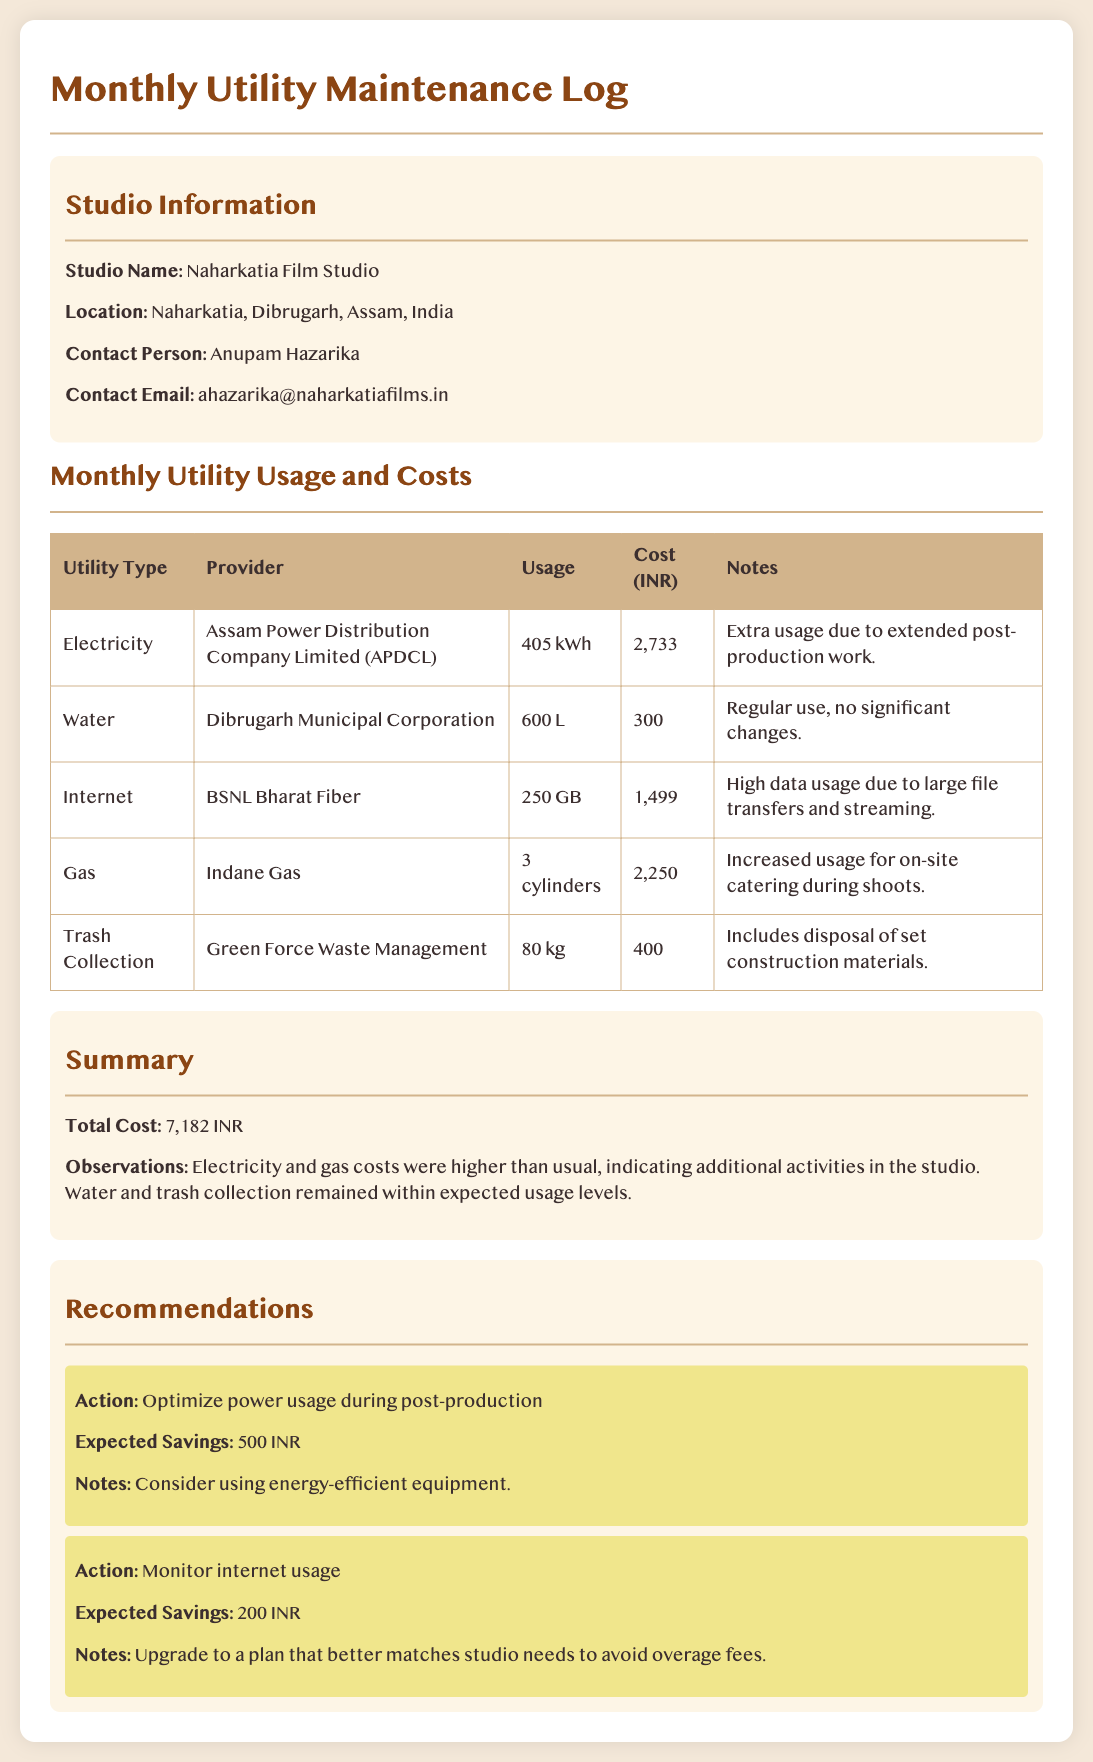What is the total cost for utilities? The total cost is mentioned in the summary section of the document, which sums all the individual utility costs.
Answer: 7,182 INR Who is the contact person for the studio? The document provides the contact person details in the studio information section.
Answer: Anupam Hazarika What utility provider supplies electricity? The utility provider for electricity is listed in the utility usage table.
Answer: Assam Power Distribution Company Limited (APDCL) How much gas was used this month? The usage of gas is specified in the utility usage table under the gas section.
Answer: 3 cylinders What was the electricity usage in kWh? The document details the electricity usage in the utilities table.
Answer: 405 kWh What recommendation is provided for power usage? The recommendations section contains specific actions suggested for optimizing power usage.
Answer: Optimize power usage during post-production What is the expected savings from monitoring internet usage? The expected savings for monitoring internet usage is stated in the recommendations section.
Answer: 200 INR What type of waste management service is mentioned? The document lists the waste management service provider in the utility usage table.
Answer: Green Force Waste Management 